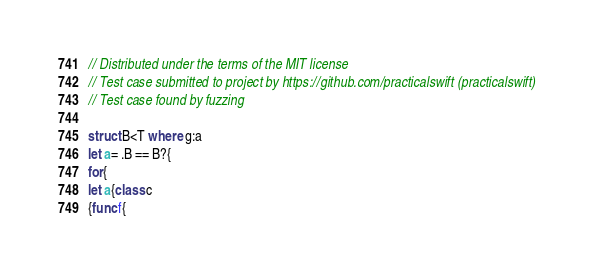<code> <loc_0><loc_0><loc_500><loc_500><_Swift_>// Distributed under the terms of the MIT license
// Test case submitted to project by https://github.com/practicalswift (practicalswift)
// Test case found by fuzzing

struct B<T where g:a
let a= .B == B?{
for{
let a{class c
{func f{</code> 